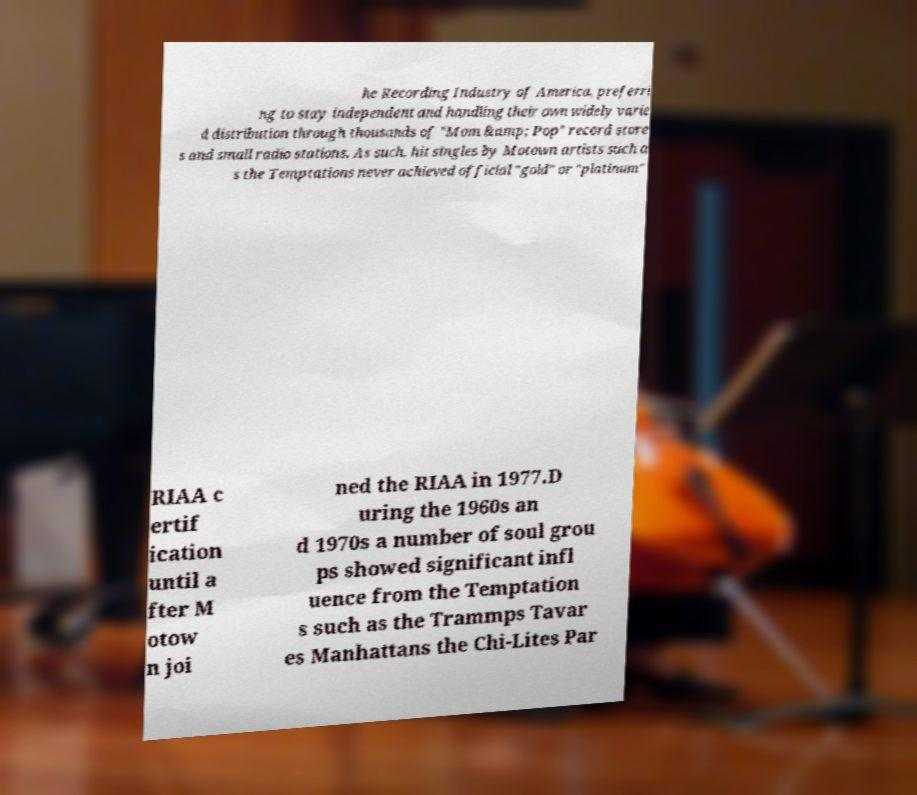Can you read and provide the text displayed in the image?This photo seems to have some interesting text. Can you extract and type it out for me? he Recording Industry of America, preferri ng to stay independent and handling their own widely varie d distribution through thousands of "Mom &amp; Pop" record store s and small radio stations. As such, hit singles by Motown artists such a s the Temptations never achieved official "gold" or "platinum" RIAA c ertif ication until a fter M otow n joi ned the RIAA in 1977.D uring the 1960s an d 1970s a number of soul grou ps showed significant infl uence from the Temptation s such as the Trammps Tavar es Manhattans the Chi-Lites Par 